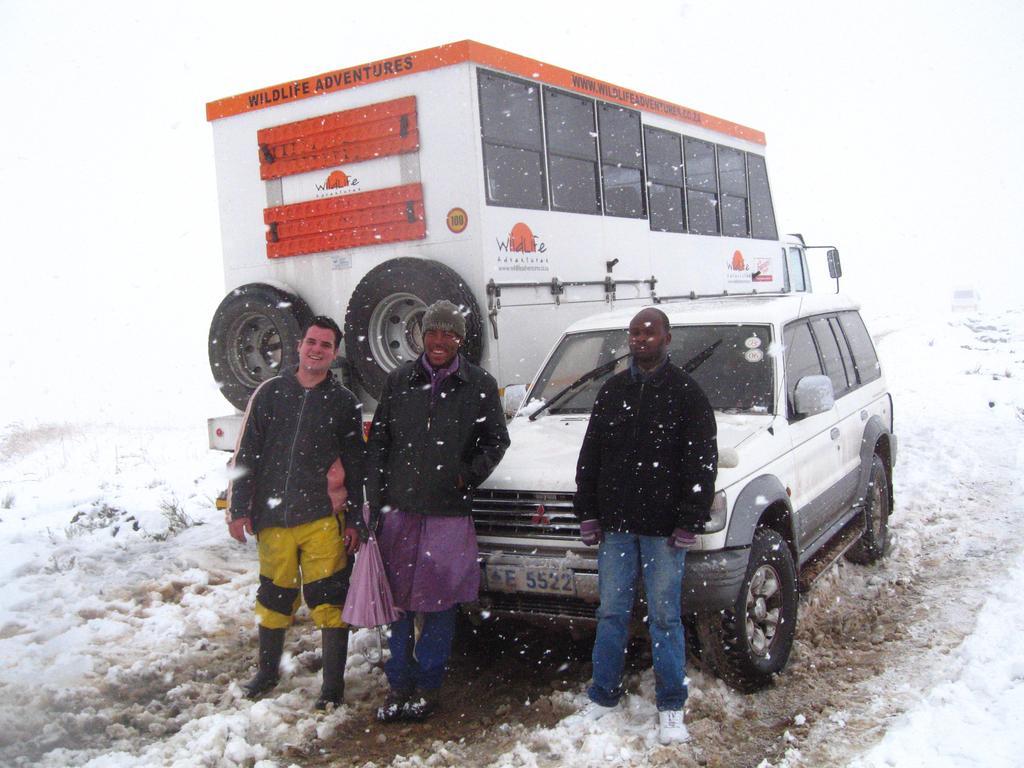Could you give a brief overview of what you see in this image? In this image in the center there are three persons who are standing and there is one vehicle, and a truck. At the bottom there is snow. 